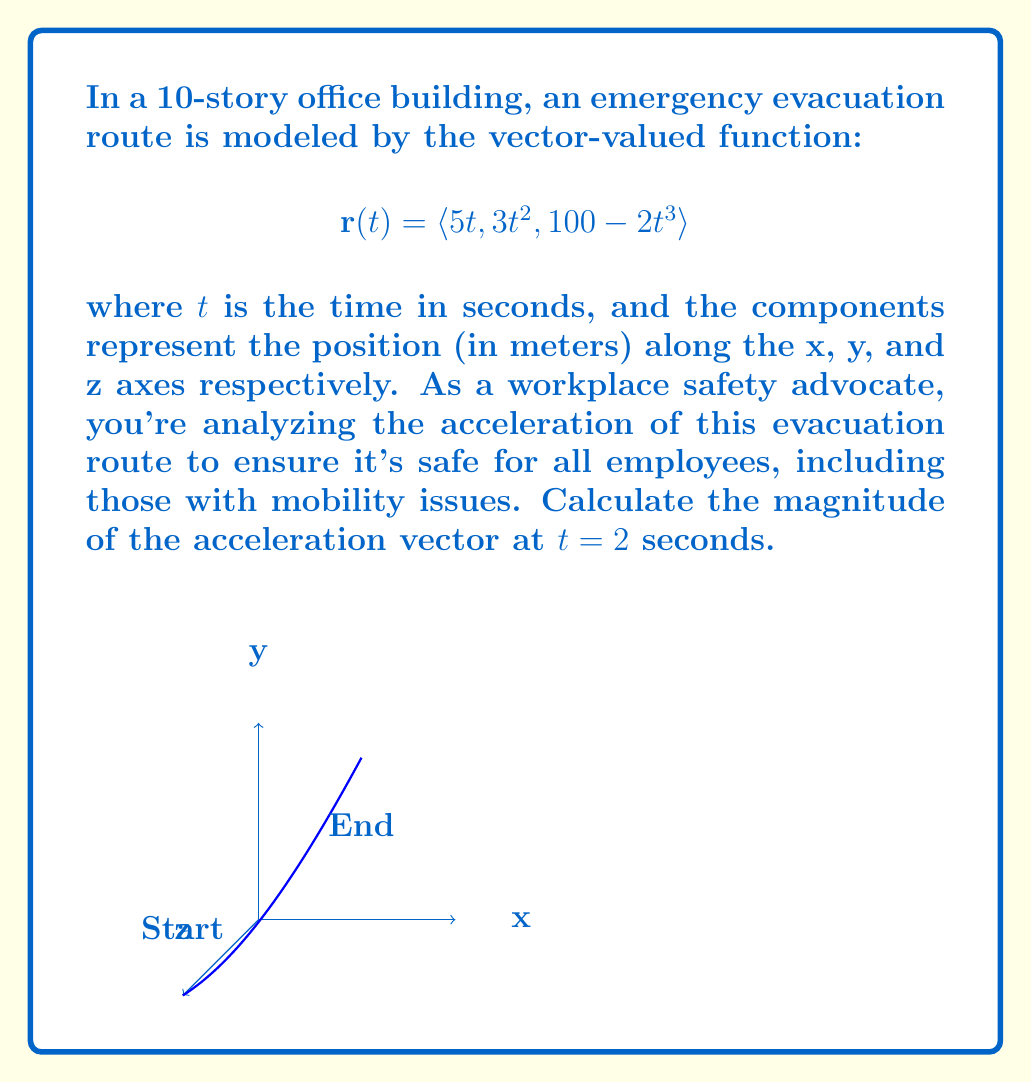Solve this math problem. Let's approach this step-by-step:

1) The acceleration vector is the second derivative of the position vector. So, we need to differentiate $\mathbf{r}(t)$ twice.

2) First derivative (velocity vector):
   $$\mathbf{v}(t) = \mathbf{r}'(t) = \langle 5, 6t, -6t^2 \rangle$$

3) Second derivative (acceleration vector):
   $$\mathbf{a}(t) = \mathbf{v}'(t) = \langle 0, 6, -12t \rangle$$

4) Now, we need to find $\mathbf{a}(2)$:
   $$\mathbf{a}(2) = \langle 0, 6, -24 \rangle$$

5) The magnitude of the acceleration vector is given by:
   $$|\mathbf{a}(2)| = \sqrt{a_x^2 + a_y^2 + a_z^2}$$

6) Substituting the values:
   $$|\mathbf{a}(2)| = \sqrt{0^2 + 6^2 + (-24)^2}$$

7) Simplifying:
   $$|\mathbf{a}(2)| = \sqrt{36 + 576} = \sqrt{612} = 6\sqrt{17}$$

Therefore, the magnitude of the acceleration vector at $t = 2$ seconds is $6\sqrt{17}$ m/s².
Answer: $6\sqrt{17}$ m/s² 